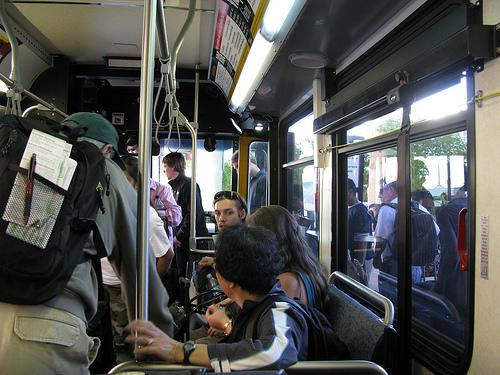Question: where are the fluorescent lights?
Choices:
A. Office ceiling.
B. Wood shop.
C. On both sides of the bus.
D. Elevator.
Answer with the letter. Answer: C Question: what mode of transportation is depicted?
Choices:
A. Train.
B. Car.
C. Bike.
D. Bus.
Answer with the letter. Answer: D Question: who is wearing a green cap?
Choices:
A. The man on the left.
B. Man on right.
C. Lady in red.
D. Woman on left.
Answer with the letter. Answer: A Question: where was this photo taken?
Choices:
A. Texas.
B. Memphis.
C. The moon.
D. On a crowded bus.
Answer with the letter. Answer: D Question: who has sunglasses on his head?
Choices:
A. Man in second seat.
B. The man in the third seat.
C. No one.
D. The man sitting in the first seat.
Answer with the letter. Answer: D 